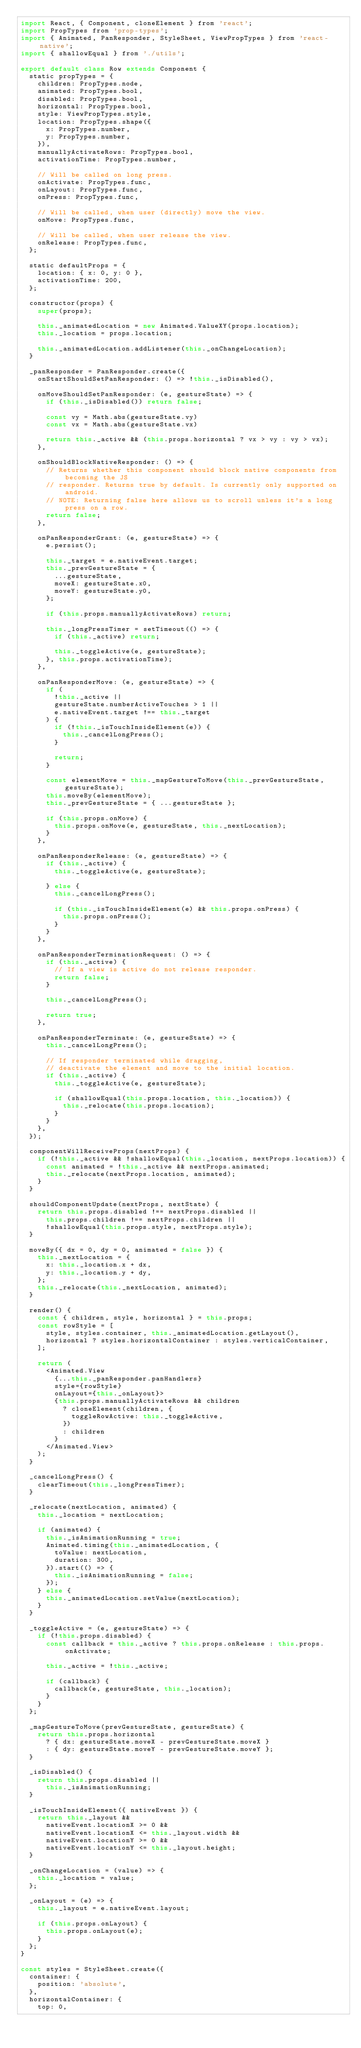Convert code to text. <code><loc_0><loc_0><loc_500><loc_500><_JavaScript_>import React, { Component, cloneElement } from 'react';
import PropTypes from 'prop-types';
import { Animated, PanResponder, StyleSheet, ViewPropTypes } from 'react-native';
import { shallowEqual } from './utils';

export default class Row extends Component {
  static propTypes = {
    children: PropTypes.node,
    animated: PropTypes.bool,
    disabled: PropTypes.bool,
    horizontal: PropTypes.bool,
    style: ViewPropTypes.style,
    location: PropTypes.shape({
      x: PropTypes.number,
      y: PropTypes.number,
    }),
    manuallyActivateRows: PropTypes.bool,
    activationTime: PropTypes.number,

    // Will be called on long press.
    onActivate: PropTypes.func,
    onLayout: PropTypes.func,
    onPress: PropTypes.func,

    // Will be called, when user (directly) move the view.
    onMove: PropTypes.func,

    // Will be called, when user release the view.
    onRelease: PropTypes.func,
  };

  static defaultProps = {
    location: { x: 0, y: 0 },
    activationTime: 200,
  };

  constructor(props) {
    super(props);

    this._animatedLocation = new Animated.ValueXY(props.location);
    this._location = props.location;

    this._animatedLocation.addListener(this._onChangeLocation);
  }

  _panResponder = PanResponder.create({
    onStartShouldSetPanResponder: () => !this._isDisabled(),

    onMoveShouldSetPanResponder: (e, gestureState) => {
      if (this._isDisabled()) return false;

      const vy = Math.abs(gestureState.vy)
      const vx = Math.abs(gestureState.vx)

      return this._active && (this.props.horizontal ? vx > vy : vy > vx);
    },

    onShouldBlockNativeResponder: () => {
      // Returns whether this component should block native components from becoming the JS
      // responder. Returns true by default. Is currently only supported on android.
      // NOTE: Returning false here allows us to scroll unless it's a long press on a row.
      return false;
    },

    onPanResponderGrant: (e, gestureState) => {
      e.persist();

      this._target = e.nativeEvent.target;
      this._prevGestureState = {
        ...gestureState,
        moveX: gestureState.x0,
        moveY: gestureState.y0,
      };

      if (this.props.manuallyActivateRows) return;

      this._longPressTimer = setTimeout(() => {
        if (this._active) return;

        this._toggleActive(e, gestureState);
      }, this.props.activationTime);
    },

    onPanResponderMove: (e, gestureState) => {
      if (
        !this._active ||
        gestureState.numberActiveTouches > 1 ||
        e.nativeEvent.target !== this._target
      ) {
        if (!this._isTouchInsideElement(e)) {
          this._cancelLongPress();
        }

        return;
      }

      const elementMove = this._mapGestureToMove(this._prevGestureState, gestureState);
      this.moveBy(elementMove);
      this._prevGestureState = { ...gestureState };

      if (this.props.onMove) {
        this.props.onMove(e, gestureState, this._nextLocation);
      }
    },

    onPanResponderRelease: (e, gestureState) => {
      if (this._active) {
        this._toggleActive(e, gestureState);

      } else {
        this._cancelLongPress();

        if (this._isTouchInsideElement(e) && this.props.onPress) {
          this.props.onPress();
        }
      }
    },

    onPanResponderTerminationRequest: () => {
      if (this._active) {
        // If a view is active do not release responder.
        return false;
      }

      this._cancelLongPress();

      return true;
    },

    onPanResponderTerminate: (e, gestureState) => {
      this._cancelLongPress();

      // If responder terminated while dragging,
      // deactivate the element and move to the initial location.
      if (this._active) {
        this._toggleActive(e, gestureState);

        if (shallowEqual(this.props.location, this._location)) {
          this._relocate(this.props.location);
        }
      }
    },
  });

  componentWillReceiveProps(nextProps) {
    if (!this._active && !shallowEqual(this._location, nextProps.location)) {
      const animated = !this._active && nextProps.animated;
      this._relocate(nextProps.location, animated);
    }
  }

  shouldComponentUpdate(nextProps, nextState) {
    return this.props.disabled !== nextProps.disabled ||
      this.props.children !== nextProps.children ||
      !shallowEqual(this.props.style, nextProps.style);
  }

  moveBy({ dx = 0, dy = 0, animated = false }) {
    this._nextLocation = {
      x: this._location.x + dx,
      y: this._location.y + dy,
    };
    this._relocate(this._nextLocation, animated);
  }

  render() {
    const { children, style, horizontal } = this.props;
    const rowStyle = [
      style, styles.container, this._animatedLocation.getLayout(),
      horizontal ? styles.horizontalContainer : styles.verticalContainer,
    ];

    return (
      <Animated.View
        {...this._panResponder.panHandlers}
        style={rowStyle}
        onLayout={this._onLayout}>
        {this.props.manuallyActivateRows && children
          ? cloneElement(children, {
            toggleRowActive: this._toggleActive,
          })
          : children
        }
      </Animated.View>
    );
  }

  _cancelLongPress() {
    clearTimeout(this._longPressTimer);
  }

  _relocate(nextLocation, animated) {
    this._location = nextLocation;

    if (animated) {
      this._isAnimationRunning = true;
      Animated.timing(this._animatedLocation, {
        toValue: nextLocation,
        duration: 300,
      }).start(() => {
        this._isAnimationRunning = false;
      });
    } else {
      this._animatedLocation.setValue(nextLocation);
    }
  }

  _toggleActive = (e, gestureState) => {
    if (!this.props.disabled) {
      const callback = this._active ? this.props.onRelease : this.props.onActivate;

      this._active = !this._active;

      if (callback) {
        callback(e, gestureState, this._location);
      }
    }
  };

  _mapGestureToMove(prevGestureState, gestureState) {
    return this.props.horizontal
      ? { dx: gestureState.moveX - prevGestureState.moveX }
      : { dy: gestureState.moveY - prevGestureState.moveY };
  }

  _isDisabled() {
    return this.props.disabled ||
      this._isAnimationRunning;
  }

  _isTouchInsideElement({ nativeEvent }) {
    return this._layout &&
      nativeEvent.locationX >= 0 &&
      nativeEvent.locationX <= this._layout.width &&
      nativeEvent.locationY >= 0 &&
      nativeEvent.locationY <= this._layout.height;
  }

  _onChangeLocation = (value) => {
    this._location = value;
  };

  _onLayout = (e) => {
    this._layout = e.nativeEvent.layout;

    if (this.props.onLayout) {
      this.props.onLayout(e);
    }
  };
}

const styles = StyleSheet.create({
  container: {
    position: 'absolute',
  },
  horizontalContainer: {
    top: 0,</code> 